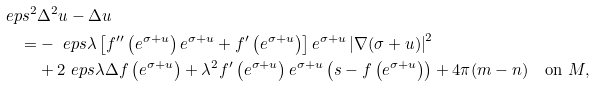Convert formula to latex. <formula><loc_0><loc_0><loc_500><loc_500>\ e p s ^ { 2 } & \Delta ^ { 2 } u - \Delta u \\ = & - \ e p s \lambda \left [ f ^ { \prime \prime } \left ( e ^ { \sigma + u } \right ) e ^ { \sigma + u } + f ^ { \prime } \left ( e ^ { \sigma + u } \right ) \right ] e ^ { \sigma + u } \left | \nabla ( \sigma + u ) \right | ^ { 2 } \\ & + 2 \ e p s \lambda \Delta f \left ( e ^ { \sigma + u } \right ) + \lambda ^ { 2 } f ^ { \prime } \left ( e ^ { \sigma + u } \right ) e ^ { \sigma + u } \left ( s - f \left ( e ^ { \sigma + u } \right ) \right ) + 4 \pi ( m - n ) \quad \text {on} \ M ,</formula> 